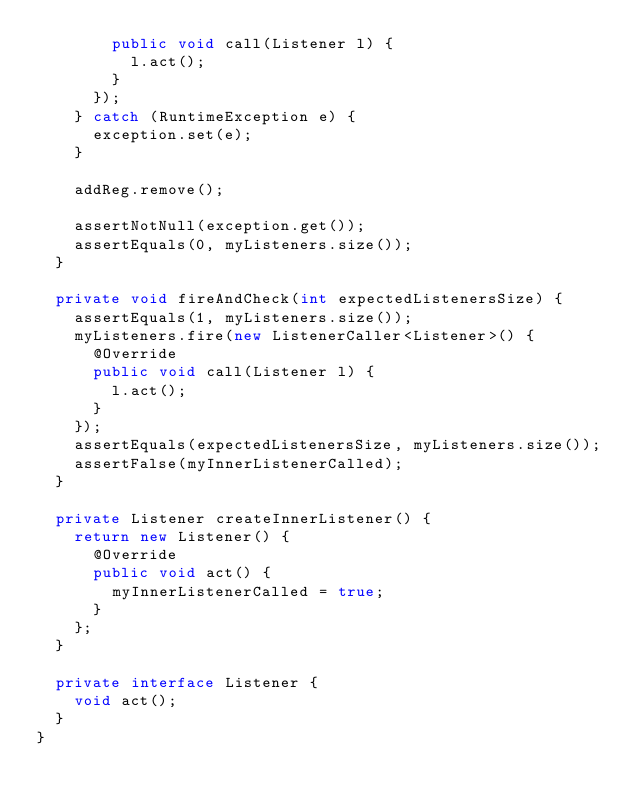<code> <loc_0><loc_0><loc_500><loc_500><_Java_>        public void call(Listener l) {
          l.act();
        }
      });
    } catch (RuntimeException e) {
      exception.set(e);
    }

    addReg.remove();

    assertNotNull(exception.get());
    assertEquals(0, myListeners.size());
  }

  private void fireAndCheck(int expectedListenersSize) {
    assertEquals(1, myListeners.size());
    myListeners.fire(new ListenerCaller<Listener>() {
      @Override
      public void call(Listener l) {
        l.act();
      }
    });
    assertEquals(expectedListenersSize, myListeners.size());
    assertFalse(myInnerListenerCalled);
  }

  private Listener createInnerListener() {
    return new Listener() {
      @Override
      public void act() {
        myInnerListenerCalled = true;
      }
    };
  }

  private interface Listener {
    void act();
  }
}</code> 